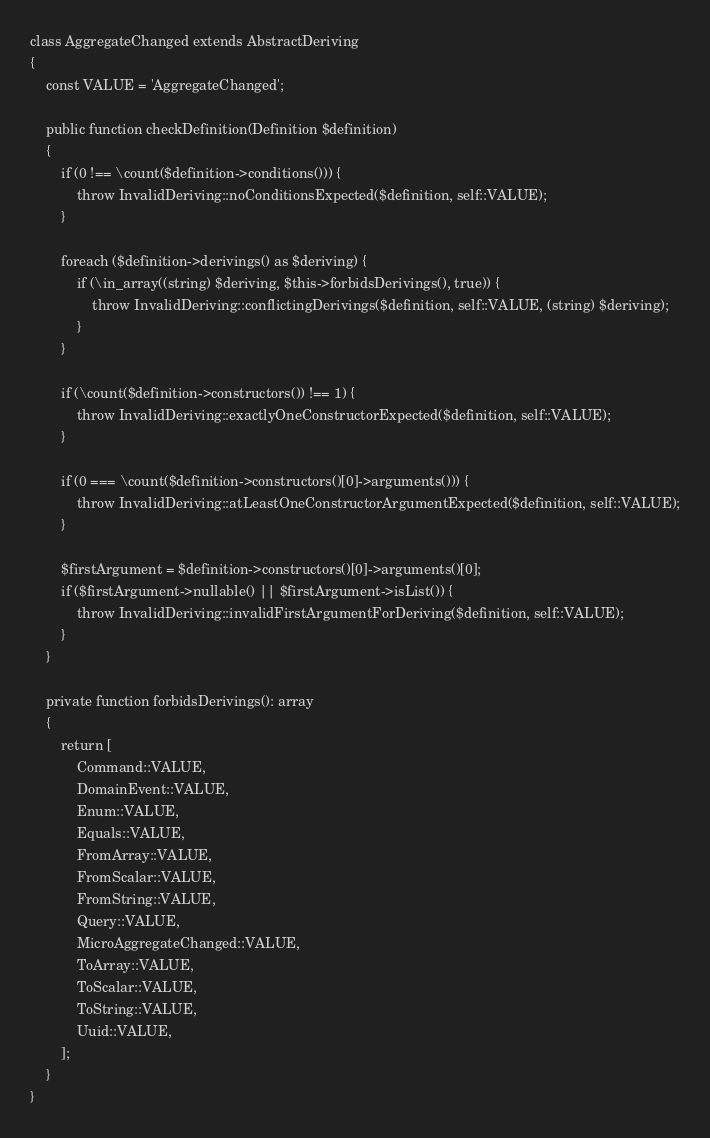<code> <loc_0><loc_0><loc_500><loc_500><_PHP_>class AggregateChanged extends AbstractDeriving
{
    const VALUE = 'AggregateChanged';

    public function checkDefinition(Definition $definition)
    {
        if (0 !== \count($definition->conditions())) {
            throw InvalidDeriving::noConditionsExpected($definition, self::VALUE);
        }

        foreach ($definition->derivings() as $deriving) {
            if (\in_array((string) $deriving, $this->forbidsDerivings(), true)) {
                throw InvalidDeriving::conflictingDerivings($definition, self::VALUE, (string) $deriving);
            }
        }

        if (\count($definition->constructors()) !== 1) {
            throw InvalidDeriving::exactlyOneConstructorExpected($definition, self::VALUE);
        }

        if (0 === \count($definition->constructors()[0]->arguments())) {
            throw InvalidDeriving::atLeastOneConstructorArgumentExpected($definition, self::VALUE);
        }

        $firstArgument = $definition->constructors()[0]->arguments()[0];
        if ($firstArgument->nullable() || $firstArgument->isList()) {
            throw InvalidDeriving::invalidFirstArgumentForDeriving($definition, self::VALUE);
        }
    }

    private function forbidsDerivings(): array
    {
        return [
            Command::VALUE,
            DomainEvent::VALUE,
            Enum::VALUE,
            Equals::VALUE,
            FromArray::VALUE,
            FromScalar::VALUE,
            FromString::VALUE,
            Query::VALUE,
            MicroAggregateChanged::VALUE,
            ToArray::VALUE,
            ToScalar::VALUE,
            ToString::VALUE,
            Uuid::VALUE,
        ];
    }
}
</code> 